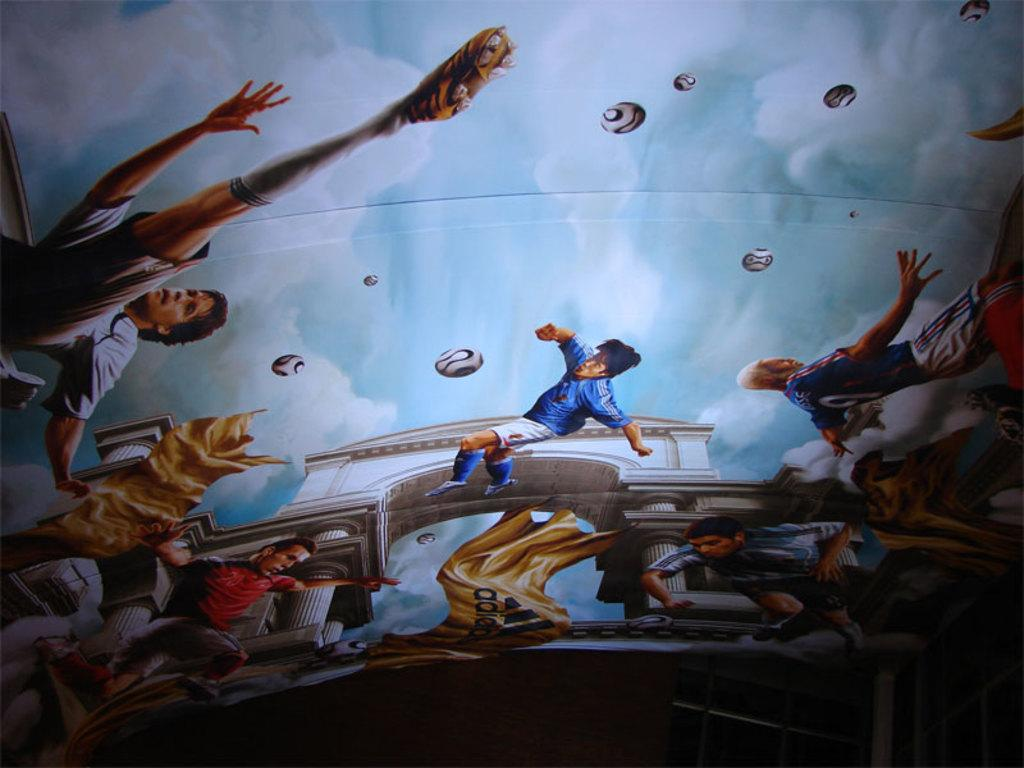What type of people can be seen in the image? There are men depicted in the image. What objects are present in the image alongside the men? There are balls in the image. How many clothes are visible in the image? There are two clothes in the image. What is written on one of the clothes? Something is written on one of the clothes. What colors can be seen in the background of the image? The background of the image has white and blue colors. What type of trail can be seen in the image? There is no trail present in the image. What kind of development is taking place in the image? The image does not depict any development or construction. 